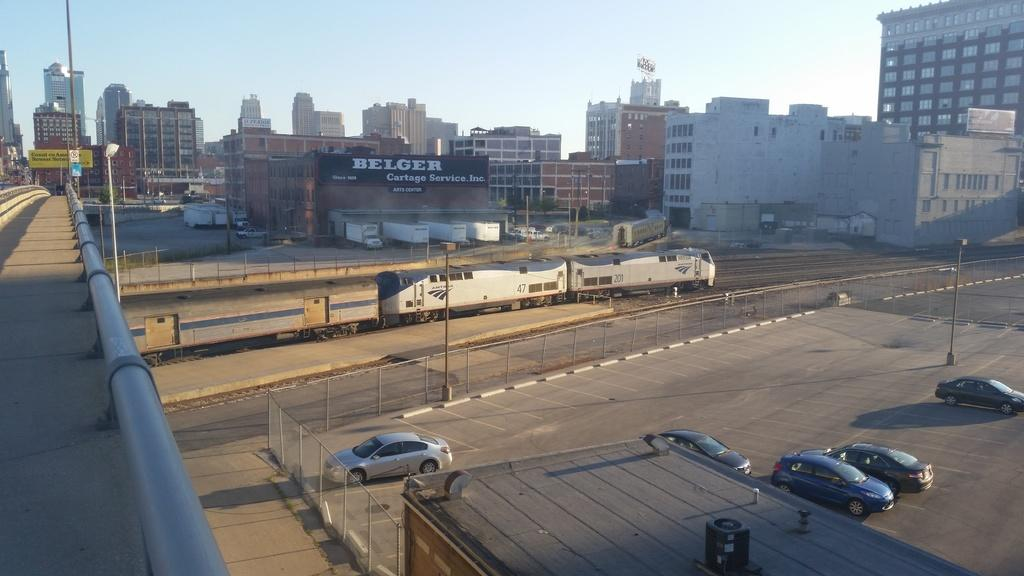What types of transportation can be seen on the road in the image? There are vehicles on the road in the image. What mode of transportation is not on the road but still present in the image? There is a train in the image. What can be seen in the background of the image? There are buildings, poles, and a hoarding in the background. What type of structure is present in the image? There is a bridge in the image. What type of coat is the machine wearing in the image? There is no machine or coat present in the image. 